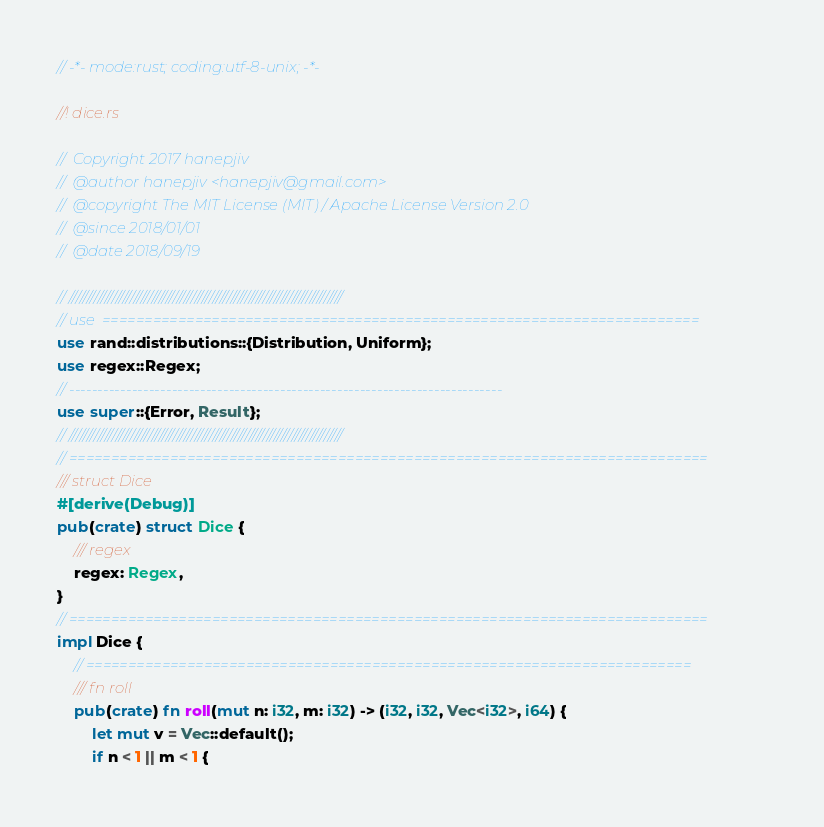<code> <loc_0><loc_0><loc_500><loc_500><_Rust_>// -*- mode:rust; coding:utf-8-unix; -*-

//! dice.rs

//  Copyright 2017 hanepjiv
//  @author hanepjiv <hanepjiv@gmail.com>
//  @copyright The MIT License (MIT) / Apache License Version 2.0
//  @since 2018/01/01
//  @date 2018/09/19

// ////////////////////////////////////////////////////////////////////////////
// use  =======================================================================
use rand::distributions::{Distribution, Uniform};
use regex::Regex;
// ----------------------------------------------------------------------------
use super::{Error, Result};
// ////////////////////////////////////////////////////////////////////////////
// ============================================================================
/// struct Dice
#[derive(Debug)]
pub(crate) struct Dice {
    /// regex
    regex: Regex,
}
// ============================================================================
impl Dice {
    // ========================================================================
    /// fn roll
    pub(crate) fn roll(mut n: i32, m: i32) -> (i32, i32, Vec<i32>, i64) {
        let mut v = Vec::default();
        if n < 1 || m < 1 {</code> 